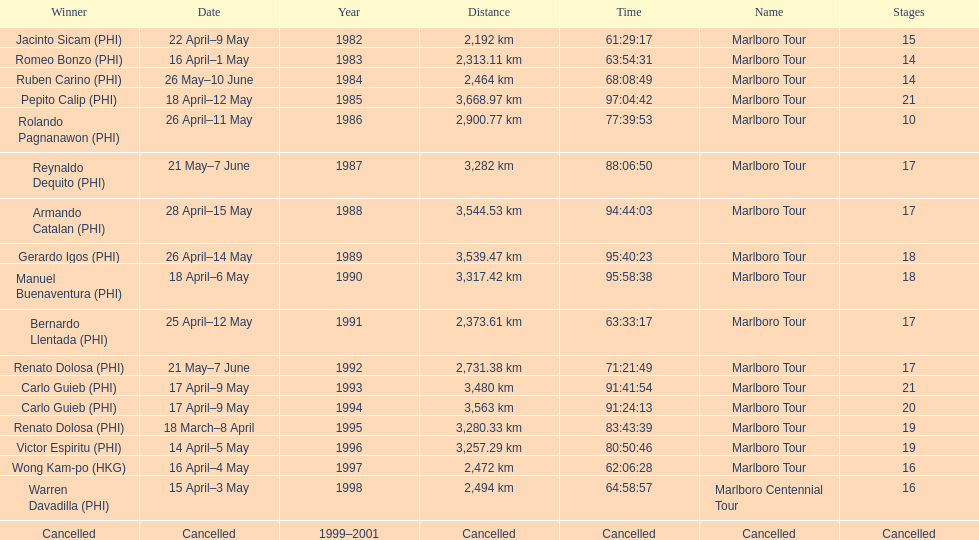What was the duration for warren davadilla to finish the 1998 marlboro centennial tour? 64:58:57. 